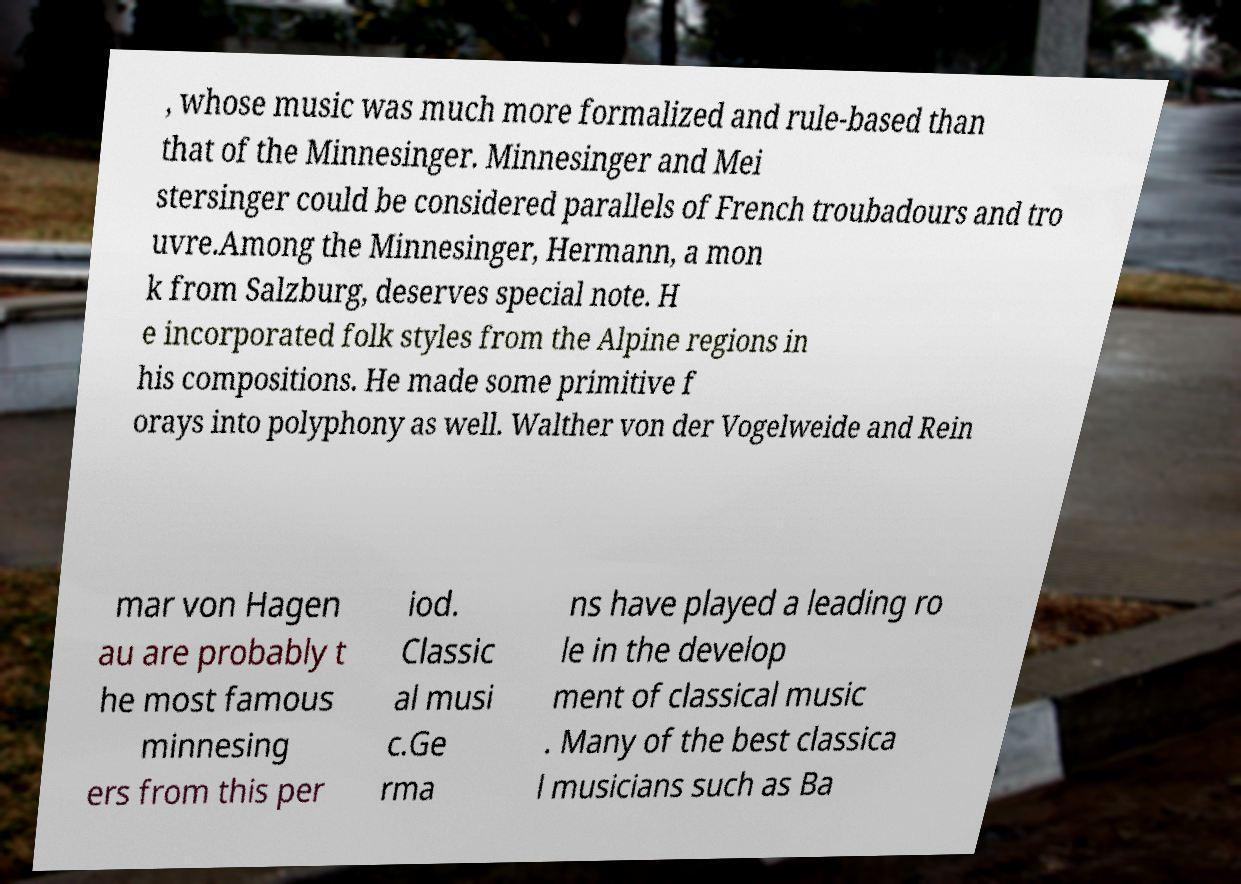Please read and relay the text visible in this image. What does it say? , whose music was much more formalized and rule-based than that of the Minnesinger. Minnesinger and Mei stersinger could be considered parallels of French troubadours and tro uvre.Among the Minnesinger, Hermann, a mon k from Salzburg, deserves special note. H e incorporated folk styles from the Alpine regions in his compositions. He made some primitive f orays into polyphony as well. Walther von der Vogelweide and Rein mar von Hagen au are probably t he most famous minnesing ers from this per iod. Classic al musi c.Ge rma ns have played a leading ro le in the develop ment of classical music . Many of the best classica l musicians such as Ba 